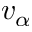<formula> <loc_0><loc_0><loc_500><loc_500>v _ { \alpha }</formula> 